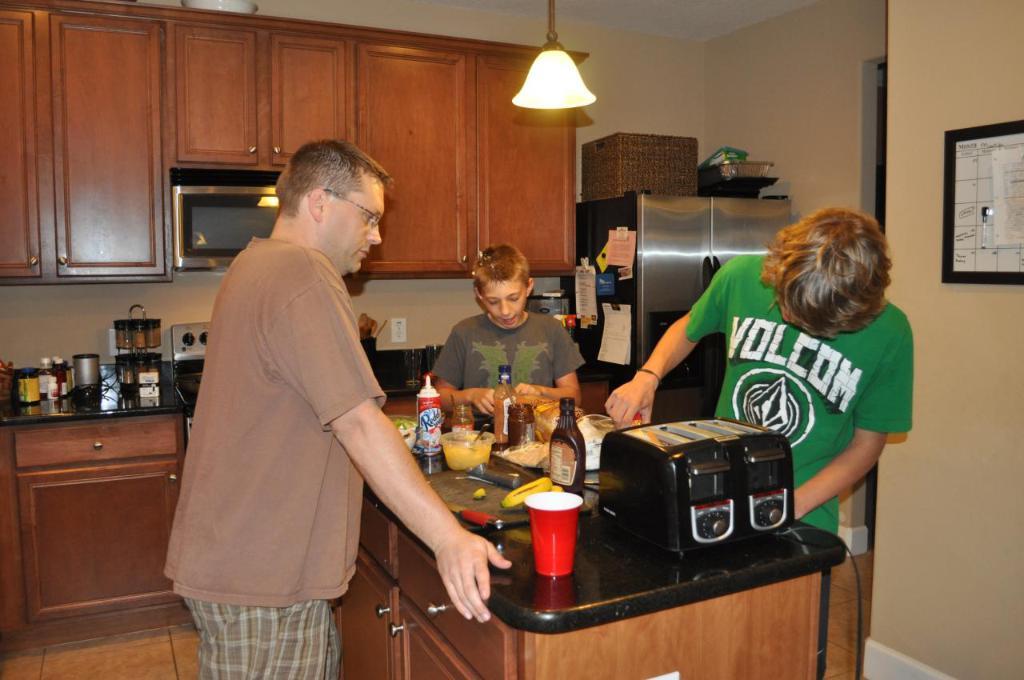What does the boy in green's shirt say?
Provide a short and direct response. Volcom. Three boys are cooking?
Give a very brief answer. Yes. 